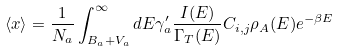Convert formula to latex. <formula><loc_0><loc_0><loc_500><loc_500>\langle x \rangle = \frac { 1 } { N _ { a } } \int _ { B _ { a } + V _ { a } } ^ { \infty } d E \gamma _ { a } ^ { \prime } \frac { I ( E ) } { \Gamma _ { T } ( E ) } C _ { i , j } \rho _ { A } ( E ) e ^ { - \beta E }</formula> 